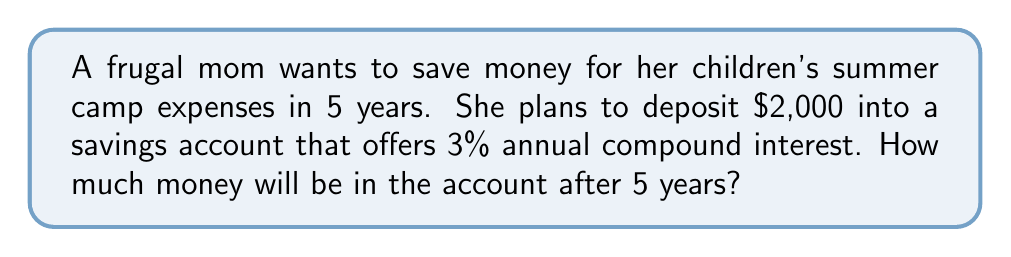Can you answer this question? To solve this problem, we'll use the compound interest formula:

$$A = P(1 + r)^n$$

Where:
$A$ = Final amount
$P$ = Principal (initial deposit)
$r$ = Annual interest rate (as a decimal)
$n$ = Number of years

Given:
$P = \$2,000$
$r = 0.03$ (3% expressed as a decimal)
$n = 5$ years

Let's substitute these values into the formula:

$$A = 2000(1 + 0.03)^5$$

Now, let's calculate step-by-step:

1) First, calculate $(1 + 0.03)^5$:
   $$(1.03)^5 = 1.159274$$

2) Multiply this result by the principal:
   $$2000 \times 1.159274 = 2318.55$$

Therefore, after 5 years, the account will contain $2,318.55.
Answer: $2,318.55 